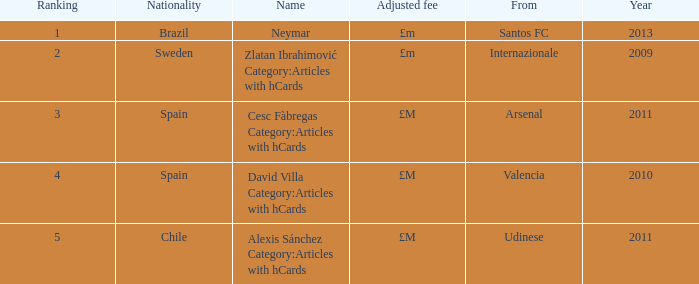What is the most recent year a player was from Valencia? 2010.0. 